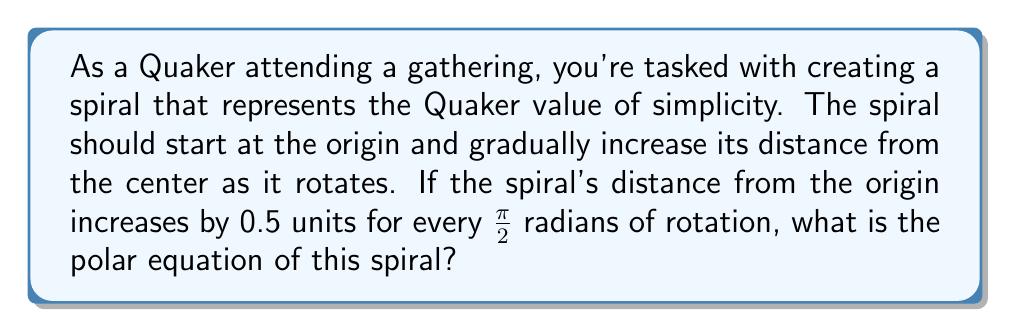Solve this math problem. To find the polar equation of this spiral, we need to follow these steps:

1) In polar coordinates, a spiral is generally represented by the equation $r = a\theta$, where $a$ is a constant that determines how quickly the spiral expands.

2) We're given that the spiral's distance from the origin increases by 0.5 units for every π/2 radians of rotation.

3) Let's set up a proportion to find the value of $a$:

   $$\frac{0.5}{\pi/2} = a$$

4) Simplify this equation:

   $$a = \frac{0.5}{\pi/2} = \frac{1}{\pi}$$

5) Therefore, our spiral equation is:

   $$r = \frac{1}{\pi}\theta$$

6) However, to truly represent simplicity, we might want to start our spiral at the origin (0,0). To do this, we don't need to modify our equation, as it already passes through the origin when $\theta = 0$.

This equation represents a simple Archimedean spiral that starts at the origin and gradually increases its distance from the center as it rotates, symbolizing the Quaker value of simplicity in its straightforward and uncomplicated form.
Answer: $$r = \frac{1}{\pi}\theta$$ 